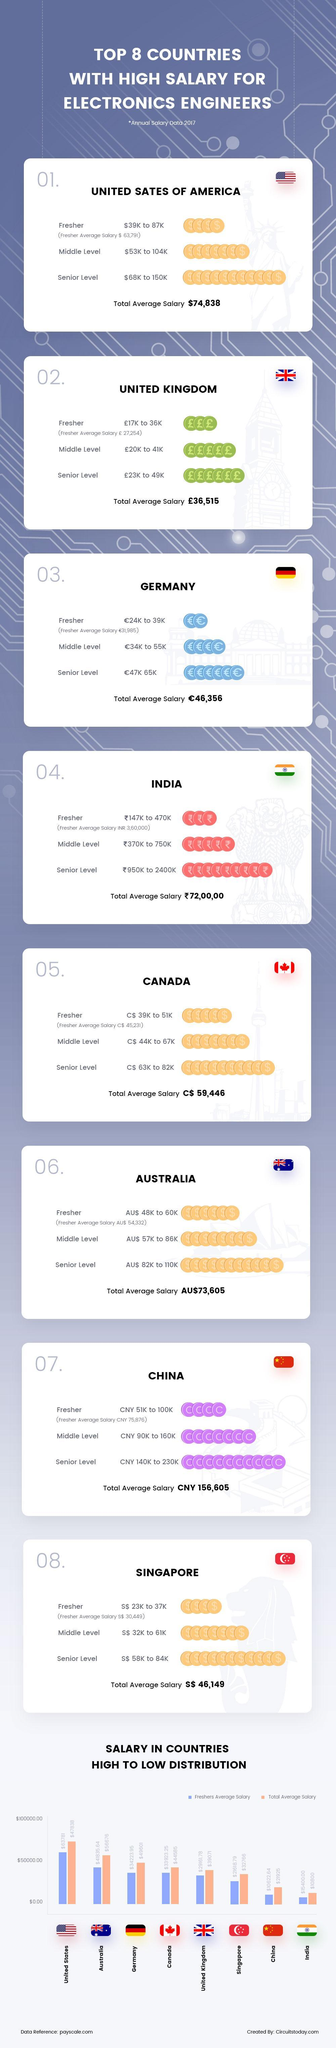What is the average salary (in pounds) for electronic engineer freshers in UK in 2017?
Answer the question with a short phrase. 27,254 What is the salary range (in pounds) for senior level electronics engineers in UK in 2017? 23K to 49K What is the total average salary of electronics engineers in India in 2017? ₹ 72,00,00 Which country offers the highest pay scale for electronics engineers among the top eight countries in 2017? UNITED STATES OF AMERICA What is the average salary for electronic engineer freshers in China in 2017? CNY 75,876 What is the salary range (in euros) for middle level electronics engineers in Germany in 2017? 34K to 55K What is the total average salary of electronics engineers in Australia in 2017? AU$73,605 